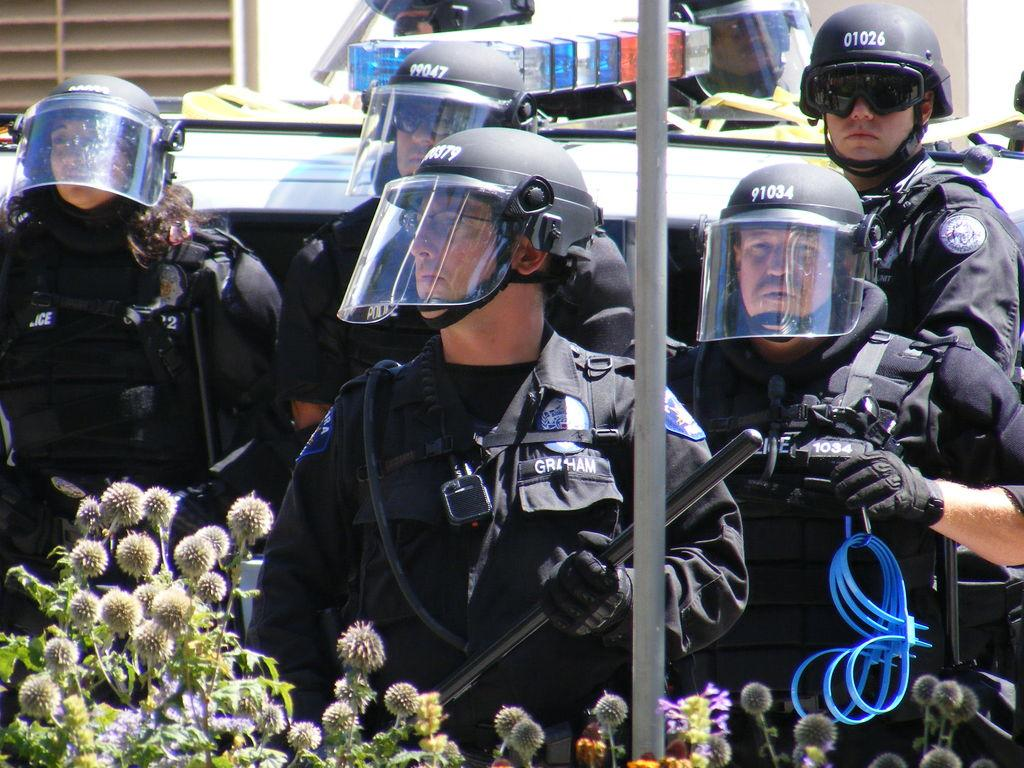What type of people can be seen in the image? There is a group of cops in the image. What color are the uniforms worn by the cops? The cops are wearing black uniforms. Where are the cops positioned in the image? The cops are standing behind a pole. What is located behind the cops? There is a vehicle behind the cops. What type of vegetation is present in the front of the image? There are unwanted plants in the front of the image. How does the crowd of people react to the popcorn being thrown off the bridge in the image? There is no crowd, popcorn, or bridge present in the image. 